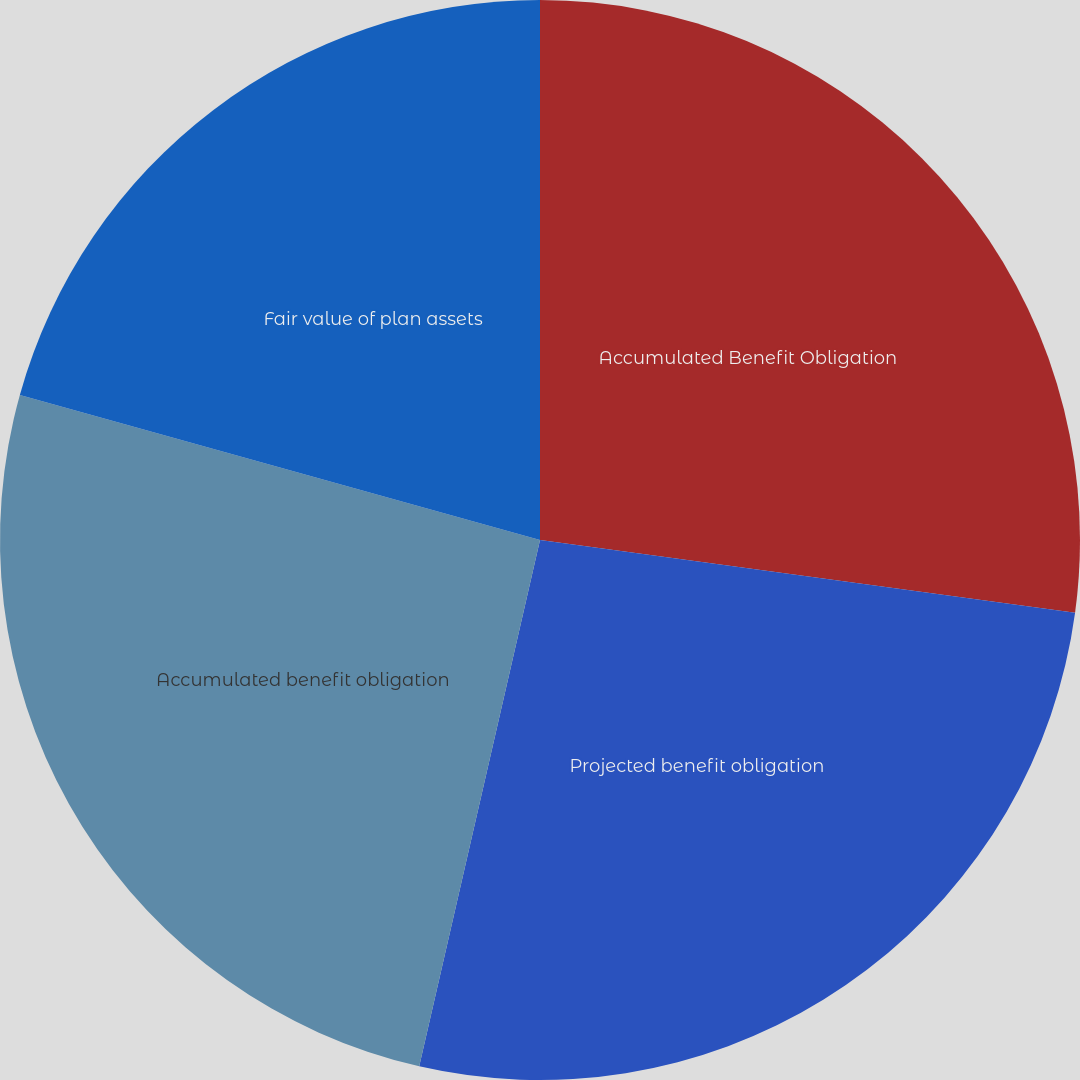Convert chart to OTSL. <chart><loc_0><loc_0><loc_500><loc_500><pie_chart><fcel>Accumulated Benefit Obligation<fcel>Projected benefit obligation<fcel>Accumulated benefit obligation<fcel>Fair value of plan assets<nl><fcel>27.15%<fcel>26.44%<fcel>25.74%<fcel>20.67%<nl></chart> 